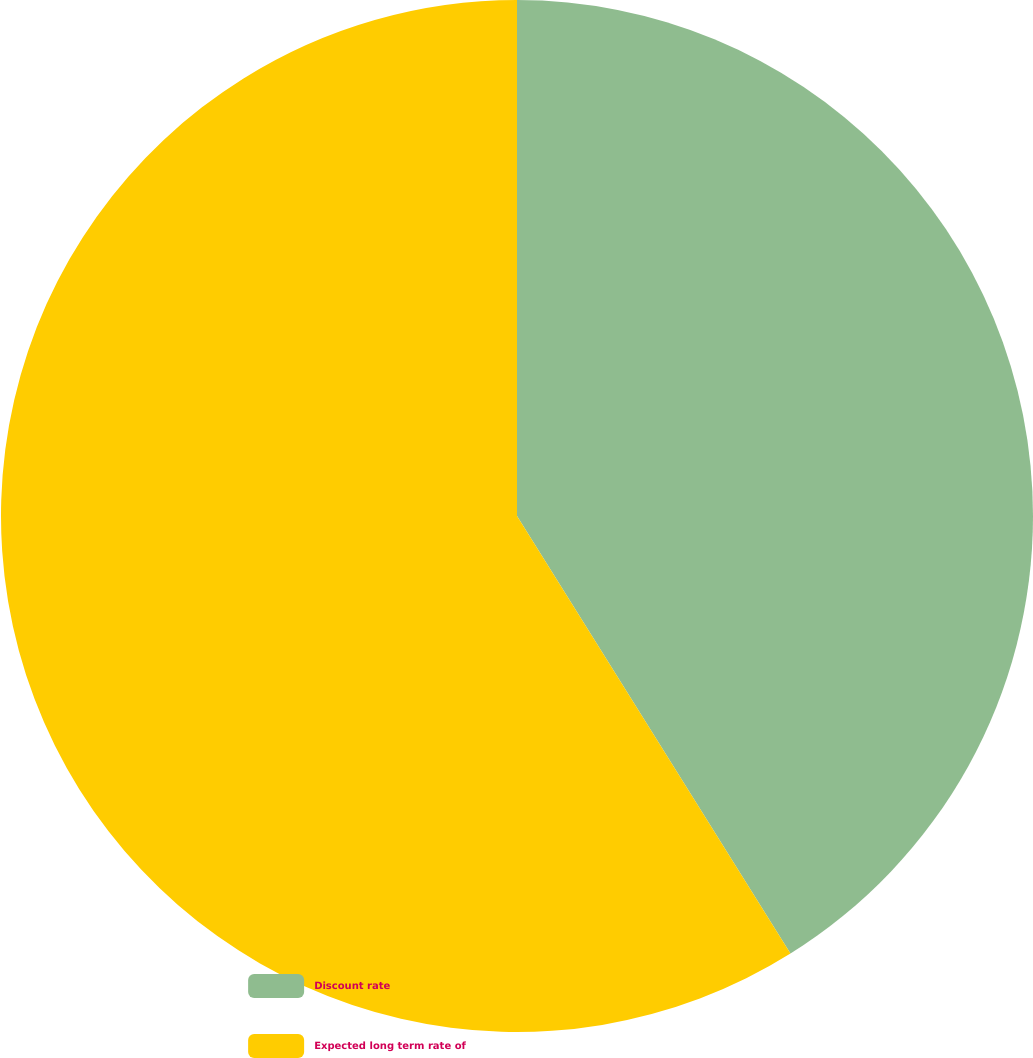<chart> <loc_0><loc_0><loc_500><loc_500><pie_chart><fcel>Discount rate<fcel>Expected long term rate of<nl><fcel>41.11%<fcel>58.89%<nl></chart> 